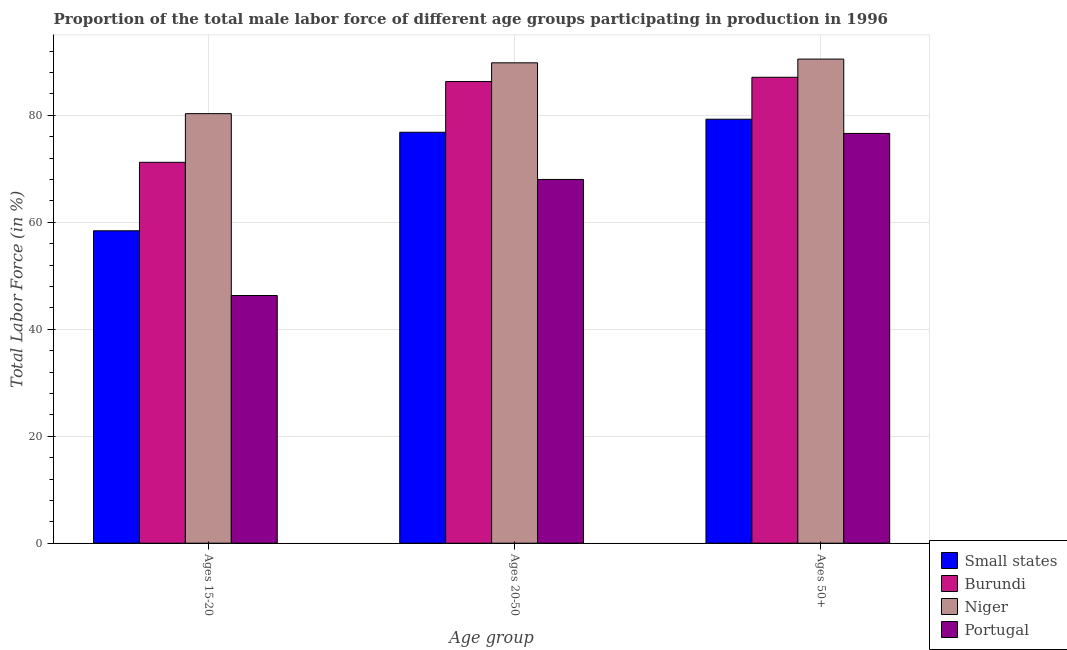How many different coloured bars are there?
Ensure brevity in your answer.  4. Are the number of bars on each tick of the X-axis equal?
Ensure brevity in your answer.  Yes. How many bars are there on the 1st tick from the left?
Ensure brevity in your answer.  4. How many bars are there on the 1st tick from the right?
Your answer should be very brief. 4. What is the label of the 1st group of bars from the left?
Make the answer very short. Ages 15-20. What is the percentage of male labor force within the age group 20-50 in Small states?
Provide a short and direct response. 76.82. Across all countries, what is the maximum percentage of male labor force within the age group 20-50?
Make the answer very short. 89.8. Across all countries, what is the minimum percentage of male labor force within the age group 15-20?
Your response must be concise. 46.3. In which country was the percentage of male labor force within the age group 20-50 maximum?
Provide a succinct answer. Niger. What is the total percentage of male labor force within the age group 20-50 in the graph?
Ensure brevity in your answer.  320.92. What is the difference between the percentage of male labor force within the age group 15-20 in Portugal and that in Burundi?
Your answer should be very brief. -24.9. What is the difference between the percentage of male labor force within the age group 20-50 in Portugal and the percentage of male labor force within the age group 15-20 in Niger?
Offer a very short reply. -12.3. What is the average percentage of male labor force within the age group 20-50 per country?
Your response must be concise. 80.23. What is the difference between the percentage of male labor force above age 50 and percentage of male labor force within the age group 20-50 in Niger?
Provide a short and direct response. 0.7. What is the ratio of the percentage of male labor force above age 50 in Burundi to that in Portugal?
Your answer should be compact. 1.14. What is the difference between the highest and the second highest percentage of male labor force within the age group 15-20?
Make the answer very short. 9.1. What is the difference between the highest and the lowest percentage of male labor force within the age group 15-20?
Your answer should be very brief. 34. Is the sum of the percentage of male labor force within the age group 20-50 in Niger and Small states greater than the maximum percentage of male labor force within the age group 15-20 across all countries?
Offer a very short reply. Yes. What does the 3rd bar from the left in Ages 15-20 represents?
Offer a terse response. Niger. What does the 2nd bar from the right in Ages 50+ represents?
Your response must be concise. Niger. Are all the bars in the graph horizontal?
Provide a succinct answer. No. Are the values on the major ticks of Y-axis written in scientific E-notation?
Provide a short and direct response. No. How many legend labels are there?
Ensure brevity in your answer.  4. How are the legend labels stacked?
Your response must be concise. Vertical. What is the title of the graph?
Your response must be concise. Proportion of the total male labor force of different age groups participating in production in 1996. Does "Turkey" appear as one of the legend labels in the graph?
Provide a succinct answer. No. What is the label or title of the X-axis?
Give a very brief answer. Age group. What is the Total Labor Force (in %) of Small states in Ages 15-20?
Keep it short and to the point. 58.4. What is the Total Labor Force (in %) in Burundi in Ages 15-20?
Provide a short and direct response. 71.2. What is the Total Labor Force (in %) of Niger in Ages 15-20?
Offer a very short reply. 80.3. What is the Total Labor Force (in %) in Portugal in Ages 15-20?
Give a very brief answer. 46.3. What is the Total Labor Force (in %) in Small states in Ages 20-50?
Offer a very short reply. 76.82. What is the Total Labor Force (in %) of Burundi in Ages 20-50?
Provide a short and direct response. 86.3. What is the Total Labor Force (in %) in Niger in Ages 20-50?
Keep it short and to the point. 89.8. What is the Total Labor Force (in %) in Small states in Ages 50+?
Keep it short and to the point. 79.26. What is the Total Labor Force (in %) of Burundi in Ages 50+?
Ensure brevity in your answer.  87.1. What is the Total Labor Force (in %) in Niger in Ages 50+?
Ensure brevity in your answer.  90.5. What is the Total Labor Force (in %) in Portugal in Ages 50+?
Your response must be concise. 76.6. Across all Age group, what is the maximum Total Labor Force (in %) of Small states?
Give a very brief answer. 79.26. Across all Age group, what is the maximum Total Labor Force (in %) in Burundi?
Offer a very short reply. 87.1. Across all Age group, what is the maximum Total Labor Force (in %) in Niger?
Make the answer very short. 90.5. Across all Age group, what is the maximum Total Labor Force (in %) of Portugal?
Provide a succinct answer. 76.6. Across all Age group, what is the minimum Total Labor Force (in %) of Small states?
Make the answer very short. 58.4. Across all Age group, what is the minimum Total Labor Force (in %) in Burundi?
Give a very brief answer. 71.2. Across all Age group, what is the minimum Total Labor Force (in %) of Niger?
Offer a very short reply. 80.3. Across all Age group, what is the minimum Total Labor Force (in %) of Portugal?
Provide a succinct answer. 46.3. What is the total Total Labor Force (in %) in Small states in the graph?
Offer a very short reply. 214.48. What is the total Total Labor Force (in %) in Burundi in the graph?
Your response must be concise. 244.6. What is the total Total Labor Force (in %) in Niger in the graph?
Make the answer very short. 260.6. What is the total Total Labor Force (in %) in Portugal in the graph?
Offer a terse response. 190.9. What is the difference between the Total Labor Force (in %) of Small states in Ages 15-20 and that in Ages 20-50?
Your response must be concise. -18.42. What is the difference between the Total Labor Force (in %) in Burundi in Ages 15-20 and that in Ages 20-50?
Keep it short and to the point. -15.1. What is the difference between the Total Labor Force (in %) in Portugal in Ages 15-20 and that in Ages 20-50?
Your answer should be very brief. -21.7. What is the difference between the Total Labor Force (in %) in Small states in Ages 15-20 and that in Ages 50+?
Offer a very short reply. -20.86. What is the difference between the Total Labor Force (in %) of Burundi in Ages 15-20 and that in Ages 50+?
Ensure brevity in your answer.  -15.9. What is the difference between the Total Labor Force (in %) in Niger in Ages 15-20 and that in Ages 50+?
Make the answer very short. -10.2. What is the difference between the Total Labor Force (in %) of Portugal in Ages 15-20 and that in Ages 50+?
Your answer should be very brief. -30.3. What is the difference between the Total Labor Force (in %) in Small states in Ages 20-50 and that in Ages 50+?
Ensure brevity in your answer.  -2.44. What is the difference between the Total Labor Force (in %) of Burundi in Ages 20-50 and that in Ages 50+?
Your answer should be compact. -0.8. What is the difference between the Total Labor Force (in %) in Small states in Ages 15-20 and the Total Labor Force (in %) in Burundi in Ages 20-50?
Your answer should be very brief. -27.9. What is the difference between the Total Labor Force (in %) of Small states in Ages 15-20 and the Total Labor Force (in %) of Niger in Ages 20-50?
Ensure brevity in your answer.  -31.4. What is the difference between the Total Labor Force (in %) in Small states in Ages 15-20 and the Total Labor Force (in %) in Portugal in Ages 20-50?
Ensure brevity in your answer.  -9.6. What is the difference between the Total Labor Force (in %) of Burundi in Ages 15-20 and the Total Labor Force (in %) of Niger in Ages 20-50?
Make the answer very short. -18.6. What is the difference between the Total Labor Force (in %) of Niger in Ages 15-20 and the Total Labor Force (in %) of Portugal in Ages 20-50?
Provide a succinct answer. 12.3. What is the difference between the Total Labor Force (in %) of Small states in Ages 15-20 and the Total Labor Force (in %) of Burundi in Ages 50+?
Your response must be concise. -28.7. What is the difference between the Total Labor Force (in %) of Small states in Ages 15-20 and the Total Labor Force (in %) of Niger in Ages 50+?
Ensure brevity in your answer.  -32.1. What is the difference between the Total Labor Force (in %) of Small states in Ages 15-20 and the Total Labor Force (in %) of Portugal in Ages 50+?
Offer a terse response. -18.2. What is the difference between the Total Labor Force (in %) in Burundi in Ages 15-20 and the Total Labor Force (in %) in Niger in Ages 50+?
Offer a very short reply. -19.3. What is the difference between the Total Labor Force (in %) in Burundi in Ages 15-20 and the Total Labor Force (in %) in Portugal in Ages 50+?
Make the answer very short. -5.4. What is the difference between the Total Labor Force (in %) in Small states in Ages 20-50 and the Total Labor Force (in %) in Burundi in Ages 50+?
Your answer should be very brief. -10.28. What is the difference between the Total Labor Force (in %) in Small states in Ages 20-50 and the Total Labor Force (in %) in Niger in Ages 50+?
Offer a very short reply. -13.68. What is the difference between the Total Labor Force (in %) of Small states in Ages 20-50 and the Total Labor Force (in %) of Portugal in Ages 50+?
Your answer should be compact. 0.22. What is the difference between the Total Labor Force (in %) in Burundi in Ages 20-50 and the Total Labor Force (in %) in Portugal in Ages 50+?
Your answer should be compact. 9.7. What is the average Total Labor Force (in %) in Small states per Age group?
Give a very brief answer. 71.49. What is the average Total Labor Force (in %) in Burundi per Age group?
Give a very brief answer. 81.53. What is the average Total Labor Force (in %) of Niger per Age group?
Provide a short and direct response. 86.87. What is the average Total Labor Force (in %) of Portugal per Age group?
Offer a terse response. 63.63. What is the difference between the Total Labor Force (in %) in Small states and Total Labor Force (in %) in Burundi in Ages 15-20?
Ensure brevity in your answer.  -12.8. What is the difference between the Total Labor Force (in %) in Small states and Total Labor Force (in %) in Niger in Ages 15-20?
Your response must be concise. -21.9. What is the difference between the Total Labor Force (in %) of Small states and Total Labor Force (in %) of Portugal in Ages 15-20?
Ensure brevity in your answer.  12.1. What is the difference between the Total Labor Force (in %) of Burundi and Total Labor Force (in %) of Niger in Ages 15-20?
Keep it short and to the point. -9.1. What is the difference between the Total Labor Force (in %) in Burundi and Total Labor Force (in %) in Portugal in Ages 15-20?
Provide a succinct answer. 24.9. What is the difference between the Total Labor Force (in %) of Niger and Total Labor Force (in %) of Portugal in Ages 15-20?
Your answer should be very brief. 34. What is the difference between the Total Labor Force (in %) of Small states and Total Labor Force (in %) of Burundi in Ages 20-50?
Offer a terse response. -9.48. What is the difference between the Total Labor Force (in %) in Small states and Total Labor Force (in %) in Niger in Ages 20-50?
Provide a short and direct response. -12.98. What is the difference between the Total Labor Force (in %) in Small states and Total Labor Force (in %) in Portugal in Ages 20-50?
Make the answer very short. 8.82. What is the difference between the Total Labor Force (in %) of Burundi and Total Labor Force (in %) of Portugal in Ages 20-50?
Keep it short and to the point. 18.3. What is the difference between the Total Labor Force (in %) of Niger and Total Labor Force (in %) of Portugal in Ages 20-50?
Keep it short and to the point. 21.8. What is the difference between the Total Labor Force (in %) in Small states and Total Labor Force (in %) in Burundi in Ages 50+?
Offer a very short reply. -7.84. What is the difference between the Total Labor Force (in %) of Small states and Total Labor Force (in %) of Niger in Ages 50+?
Give a very brief answer. -11.24. What is the difference between the Total Labor Force (in %) in Small states and Total Labor Force (in %) in Portugal in Ages 50+?
Provide a short and direct response. 2.66. What is the difference between the Total Labor Force (in %) of Burundi and Total Labor Force (in %) of Portugal in Ages 50+?
Your response must be concise. 10.5. What is the difference between the Total Labor Force (in %) of Niger and Total Labor Force (in %) of Portugal in Ages 50+?
Your answer should be very brief. 13.9. What is the ratio of the Total Labor Force (in %) of Small states in Ages 15-20 to that in Ages 20-50?
Your answer should be compact. 0.76. What is the ratio of the Total Labor Force (in %) in Burundi in Ages 15-20 to that in Ages 20-50?
Give a very brief answer. 0.82. What is the ratio of the Total Labor Force (in %) of Niger in Ages 15-20 to that in Ages 20-50?
Offer a terse response. 0.89. What is the ratio of the Total Labor Force (in %) of Portugal in Ages 15-20 to that in Ages 20-50?
Ensure brevity in your answer.  0.68. What is the ratio of the Total Labor Force (in %) in Small states in Ages 15-20 to that in Ages 50+?
Provide a succinct answer. 0.74. What is the ratio of the Total Labor Force (in %) in Burundi in Ages 15-20 to that in Ages 50+?
Give a very brief answer. 0.82. What is the ratio of the Total Labor Force (in %) of Niger in Ages 15-20 to that in Ages 50+?
Your response must be concise. 0.89. What is the ratio of the Total Labor Force (in %) of Portugal in Ages 15-20 to that in Ages 50+?
Your answer should be very brief. 0.6. What is the ratio of the Total Labor Force (in %) in Small states in Ages 20-50 to that in Ages 50+?
Your answer should be very brief. 0.97. What is the ratio of the Total Labor Force (in %) of Niger in Ages 20-50 to that in Ages 50+?
Give a very brief answer. 0.99. What is the ratio of the Total Labor Force (in %) in Portugal in Ages 20-50 to that in Ages 50+?
Your answer should be compact. 0.89. What is the difference between the highest and the second highest Total Labor Force (in %) in Small states?
Your answer should be compact. 2.44. What is the difference between the highest and the second highest Total Labor Force (in %) in Portugal?
Your response must be concise. 8.6. What is the difference between the highest and the lowest Total Labor Force (in %) of Small states?
Keep it short and to the point. 20.86. What is the difference between the highest and the lowest Total Labor Force (in %) in Portugal?
Offer a very short reply. 30.3. 